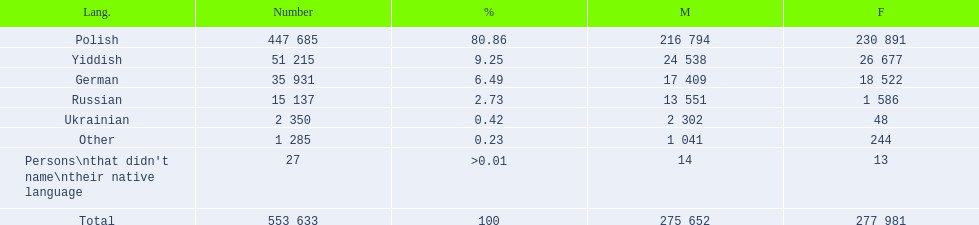How many speakers (of any language) are represented on the table ? 553 633. 